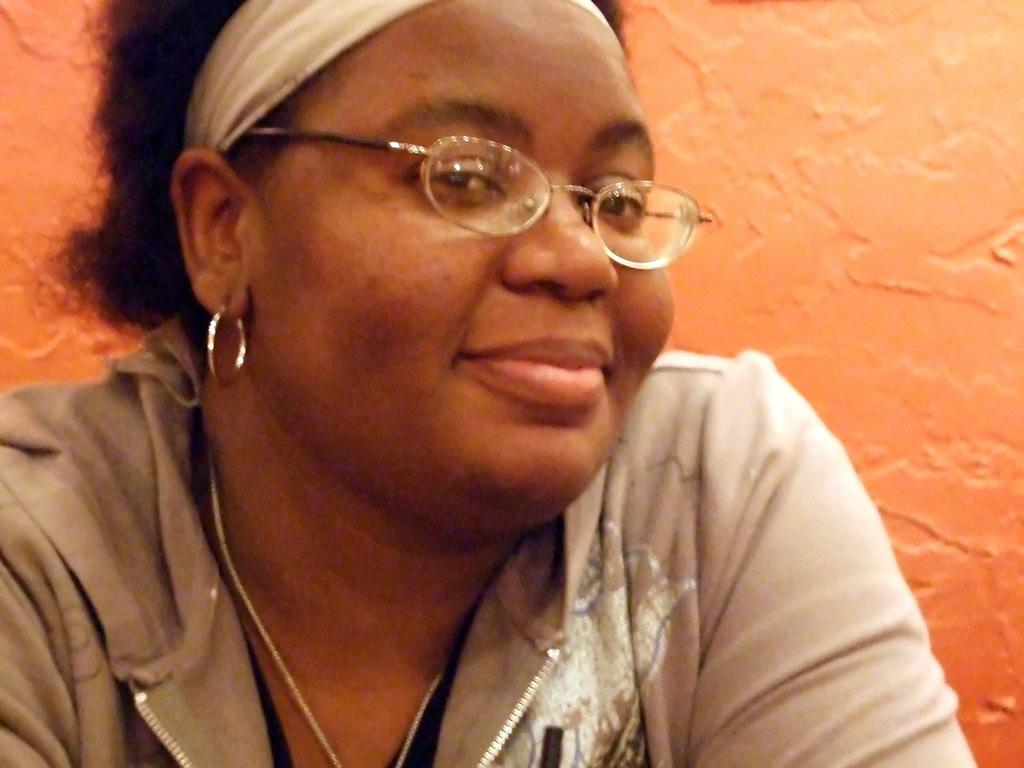Who is present in the image? There is a woman in the picture. What is the woman's facial expression? The woman is smiling. What accessory is the woman wearing? The woman is wearing spectacles. What type of locket can be seen hanging from the woman's neck in the image? There is no locket visible in the image; the woman is only wearing spectacles. 